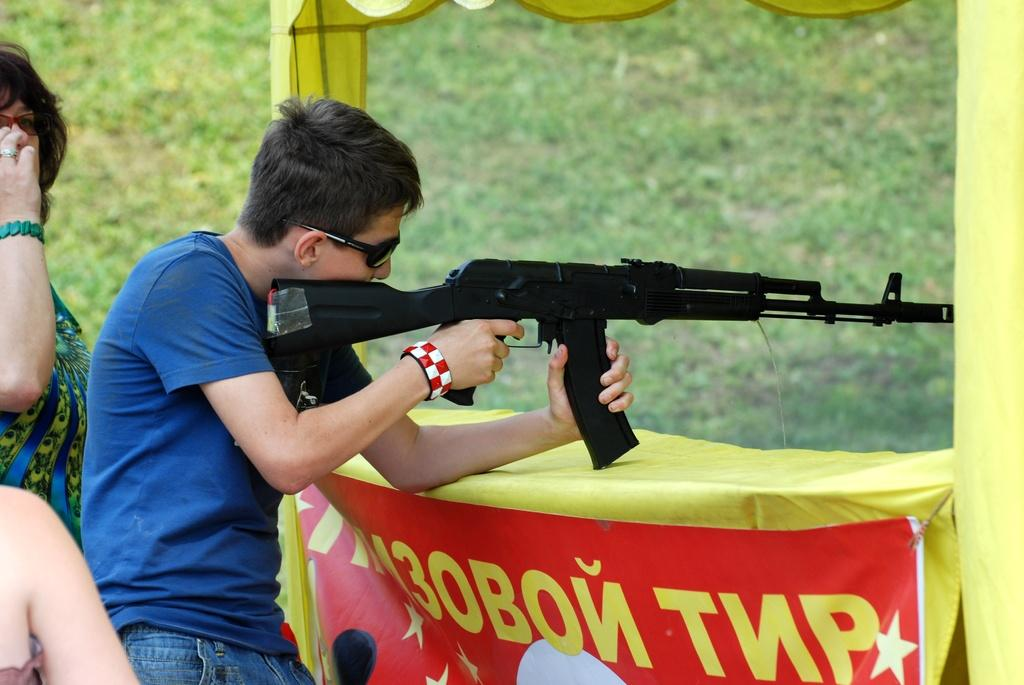What is the man in the image holding? The man is holding a gun in the image. How many people are on the left side of the image? There are two persons on the left side of the image. What can be seen in the background of the image? There is a banner and grass visible in the background of the image. How many fingers can be seen on the legs of the man in the image? There are no fingers visible on the legs of the man in the image, as the image does not show the man's legs. 